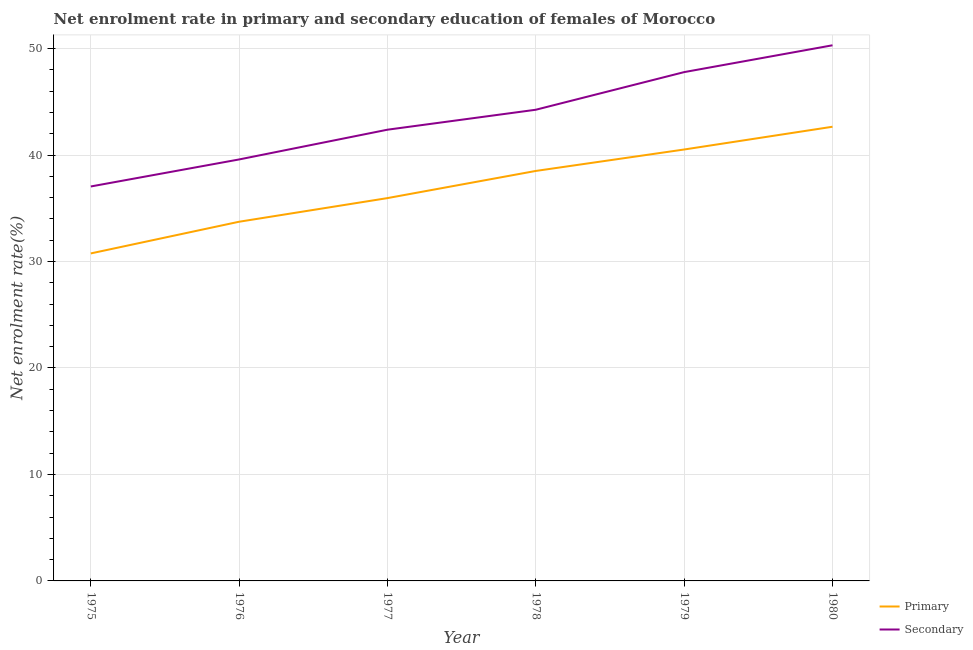Does the line corresponding to enrollment rate in primary education intersect with the line corresponding to enrollment rate in secondary education?
Your response must be concise. No. What is the enrollment rate in primary education in 1980?
Keep it short and to the point. 42.65. Across all years, what is the maximum enrollment rate in secondary education?
Provide a succinct answer. 50.31. Across all years, what is the minimum enrollment rate in primary education?
Give a very brief answer. 30.76. In which year was the enrollment rate in secondary education minimum?
Your answer should be compact. 1975. What is the total enrollment rate in primary education in the graph?
Keep it short and to the point. 222.12. What is the difference between the enrollment rate in secondary education in 1976 and that in 1979?
Your answer should be compact. -8.2. What is the difference between the enrollment rate in primary education in 1976 and the enrollment rate in secondary education in 1977?
Your answer should be very brief. -8.64. What is the average enrollment rate in primary education per year?
Make the answer very short. 37.02. In the year 1978, what is the difference between the enrollment rate in primary education and enrollment rate in secondary education?
Your answer should be compact. -5.75. What is the ratio of the enrollment rate in primary education in 1976 to that in 1980?
Provide a short and direct response. 0.79. Is the enrollment rate in secondary education in 1977 less than that in 1978?
Your answer should be compact. Yes. Is the difference between the enrollment rate in secondary education in 1976 and 1980 greater than the difference between the enrollment rate in primary education in 1976 and 1980?
Offer a very short reply. No. What is the difference between the highest and the second highest enrollment rate in primary education?
Offer a terse response. 2.14. What is the difference between the highest and the lowest enrollment rate in primary education?
Provide a short and direct response. 11.9. Is the sum of the enrollment rate in secondary education in 1978 and 1979 greater than the maximum enrollment rate in primary education across all years?
Provide a succinct answer. Yes. Does the enrollment rate in primary education monotonically increase over the years?
Make the answer very short. Yes. Is the enrollment rate in secondary education strictly greater than the enrollment rate in primary education over the years?
Your response must be concise. Yes. Does the graph contain any zero values?
Your answer should be compact. No. Does the graph contain grids?
Offer a very short reply. Yes. Where does the legend appear in the graph?
Provide a succinct answer. Bottom right. How many legend labels are there?
Give a very brief answer. 2. How are the legend labels stacked?
Give a very brief answer. Vertical. What is the title of the graph?
Your answer should be compact. Net enrolment rate in primary and secondary education of females of Morocco. What is the label or title of the Y-axis?
Provide a short and direct response. Net enrolment rate(%). What is the Net enrolment rate(%) in Primary in 1975?
Your answer should be very brief. 30.76. What is the Net enrolment rate(%) of Secondary in 1975?
Offer a very short reply. 37.05. What is the Net enrolment rate(%) of Primary in 1976?
Your answer should be very brief. 33.73. What is the Net enrolment rate(%) in Secondary in 1976?
Offer a very short reply. 39.58. What is the Net enrolment rate(%) of Primary in 1977?
Provide a short and direct response. 35.95. What is the Net enrolment rate(%) in Secondary in 1977?
Give a very brief answer. 42.38. What is the Net enrolment rate(%) of Primary in 1978?
Make the answer very short. 38.5. What is the Net enrolment rate(%) of Secondary in 1978?
Your answer should be very brief. 44.25. What is the Net enrolment rate(%) of Primary in 1979?
Provide a succinct answer. 40.52. What is the Net enrolment rate(%) of Secondary in 1979?
Keep it short and to the point. 47.79. What is the Net enrolment rate(%) in Primary in 1980?
Give a very brief answer. 42.65. What is the Net enrolment rate(%) in Secondary in 1980?
Ensure brevity in your answer.  50.31. Across all years, what is the maximum Net enrolment rate(%) in Primary?
Your answer should be very brief. 42.65. Across all years, what is the maximum Net enrolment rate(%) in Secondary?
Offer a terse response. 50.31. Across all years, what is the minimum Net enrolment rate(%) in Primary?
Ensure brevity in your answer.  30.76. Across all years, what is the minimum Net enrolment rate(%) in Secondary?
Keep it short and to the point. 37.05. What is the total Net enrolment rate(%) of Primary in the graph?
Provide a short and direct response. 222.12. What is the total Net enrolment rate(%) of Secondary in the graph?
Your answer should be compact. 261.35. What is the difference between the Net enrolment rate(%) in Primary in 1975 and that in 1976?
Provide a short and direct response. -2.98. What is the difference between the Net enrolment rate(%) of Secondary in 1975 and that in 1976?
Keep it short and to the point. -2.54. What is the difference between the Net enrolment rate(%) of Primary in 1975 and that in 1977?
Provide a succinct answer. -5.2. What is the difference between the Net enrolment rate(%) of Secondary in 1975 and that in 1977?
Ensure brevity in your answer.  -5.33. What is the difference between the Net enrolment rate(%) in Primary in 1975 and that in 1978?
Your answer should be compact. -7.75. What is the difference between the Net enrolment rate(%) in Secondary in 1975 and that in 1978?
Keep it short and to the point. -7.21. What is the difference between the Net enrolment rate(%) in Primary in 1975 and that in 1979?
Your response must be concise. -9.76. What is the difference between the Net enrolment rate(%) in Secondary in 1975 and that in 1979?
Provide a succinct answer. -10.74. What is the difference between the Net enrolment rate(%) in Primary in 1975 and that in 1980?
Your answer should be very brief. -11.9. What is the difference between the Net enrolment rate(%) of Secondary in 1975 and that in 1980?
Provide a succinct answer. -13.26. What is the difference between the Net enrolment rate(%) in Primary in 1976 and that in 1977?
Provide a short and direct response. -2.22. What is the difference between the Net enrolment rate(%) of Secondary in 1976 and that in 1977?
Offer a terse response. -2.79. What is the difference between the Net enrolment rate(%) in Primary in 1976 and that in 1978?
Keep it short and to the point. -4.77. What is the difference between the Net enrolment rate(%) of Secondary in 1976 and that in 1978?
Your answer should be compact. -4.67. What is the difference between the Net enrolment rate(%) of Primary in 1976 and that in 1979?
Ensure brevity in your answer.  -6.78. What is the difference between the Net enrolment rate(%) of Secondary in 1976 and that in 1979?
Your answer should be compact. -8.2. What is the difference between the Net enrolment rate(%) in Primary in 1976 and that in 1980?
Give a very brief answer. -8.92. What is the difference between the Net enrolment rate(%) in Secondary in 1976 and that in 1980?
Make the answer very short. -10.72. What is the difference between the Net enrolment rate(%) in Primary in 1977 and that in 1978?
Make the answer very short. -2.55. What is the difference between the Net enrolment rate(%) of Secondary in 1977 and that in 1978?
Keep it short and to the point. -1.87. What is the difference between the Net enrolment rate(%) in Primary in 1977 and that in 1979?
Offer a very short reply. -4.56. What is the difference between the Net enrolment rate(%) of Secondary in 1977 and that in 1979?
Your answer should be very brief. -5.41. What is the difference between the Net enrolment rate(%) of Primary in 1977 and that in 1980?
Your answer should be very brief. -6.7. What is the difference between the Net enrolment rate(%) of Secondary in 1977 and that in 1980?
Your answer should be compact. -7.93. What is the difference between the Net enrolment rate(%) in Primary in 1978 and that in 1979?
Provide a short and direct response. -2.01. What is the difference between the Net enrolment rate(%) in Secondary in 1978 and that in 1979?
Offer a terse response. -3.53. What is the difference between the Net enrolment rate(%) of Primary in 1978 and that in 1980?
Your response must be concise. -4.15. What is the difference between the Net enrolment rate(%) in Secondary in 1978 and that in 1980?
Offer a very short reply. -6.05. What is the difference between the Net enrolment rate(%) in Primary in 1979 and that in 1980?
Provide a short and direct response. -2.14. What is the difference between the Net enrolment rate(%) of Secondary in 1979 and that in 1980?
Offer a terse response. -2.52. What is the difference between the Net enrolment rate(%) in Primary in 1975 and the Net enrolment rate(%) in Secondary in 1976?
Provide a short and direct response. -8.83. What is the difference between the Net enrolment rate(%) in Primary in 1975 and the Net enrolment rate(%) in Secondary in 1977?
Offer a very short reply. -11.62. What is the difference between the Net enrolment rate(%) of Primary in 1975 and the Net enrolment rate(%) of Secondary in 1978?
Ensure brevity in your answer.  -13.49. What is the difference between the Net enrolment rate(%) in Primary in 1975 and the Net enrolment rate(%) in Secondary in 1979?
Provide a short and direct response. -17.03. What is the difference between the Net enrolment rate(%) of Primary in 1975 and the Net enrolment rate(%) of Secondary in 1980?
Keep it short and to the point. -19.55. What is the difference between the Net enrolment rate(%) of Primary in 1976 and the Net enrolment rate(%) of Secondary in 1977?
Make the answer very short. -8.64. What is the difference between the Net enrolment rate(%) of Primary in 1976 and the Net enrolment rate(%) of Secondary in 1978?
Give a very brief answer. -10.52. What is the difference between the Net enrolment rate(%) in Primary in 1976 and the Net enrolment rate(%) in Secondary in 1979?
Ensure brevity in your answer.  -14.05. What is the difference between the Net enrolment rate(%) in Primary in 1976 and the Net enrolment rate(%) in Secondary in 1980?
Keep it short and to the point. -16.57. What is the difference between the Net enrolment rate(%) of Primary in 1977 and the Net enrolment rate(%) of Secondary in 1978?
Provide a short and direct response. -8.3. What is the difference between the Net enrolment rate(%) in Primary in 1977 and the Net enrolment rate(%) in Secondary in 1979?
Your answer should be compact. -11.83. What is the difference between the Net enrolment rate(%) of Primary in 1977 and the Net enrolment rate(%) of Secondary in 1980?
Ensure brevity in your answer.  -14.35. What is the difference between the Net enrolment rate(%) of Primary in 1978 and the Net enrolment rate(%) of Secondary in 1979?
Provide a succinct answer. -9.28. What is the difference between the Net enrolment rate(%) in Primary in 1978 and the Net enrolment rate(%) in Secondary in 1980?
Your answer should be very brief. -11.8. What is the difference between the Net enrolment rate(%) in Primary in 1979 and the Net enrolment rate(%) in Secondary in 1980?
Provide a short and direct response. -9.79. What is the average Net enrolment rate(%) in Primary per year?
Provide a short and direct response. 37.02. What is the average Net enrolment rate(%) of Secondary per year?
Keep it short and to the point. 43.56. In the year 1975, what is the difference between the Net enrolment rate(%) of Primary and Net enrolment rate(%) of Secondary?
Give a very brief answer. -6.29. In the year 1976, what is the difference between the Net enrolment rate(%) in Primary and Net enrolment rate(%) in Secondary?
Your answer should be compact. -5.85. In the year 1977, what is the difference between the Net enrolment rate(%) in Primary and Net enrolment rate(%) in Secondary?
Ensure brevity in your answer.  -6.42. In the year 1978, what is the difference between the Net enrolment rate(%) in Primary and Net enrolment rate(%) in Secondary?
Your answer should be very brief. -5.75. In the year 1979, what is the difference between the Net enrolment rate(%) of Primary and Net enrolment rate(%) of Secondary?
Your answer should be compact. -7.27. In the year 1980, what is the difference between the Net enrolment rate(%) of Primary and Net enrolment rate(%) of Secondary?
Make the answer very short. -7.65. What is the ratio of the Net enrolment rate(%) of Primary in 1975 to that in 1976?
Your answer should be compact. 0.91. What is the ratio of the Net enrolment rate(%) in Secondary in 1975 to that in 1976?
Your answer should be compact. 0.94. What is the ratio of the Net enrolment rate(%) in Primary in 1975 to that in 1977?
Give a very brief answer. 0.86. What is the ratio of the Net enrolment rate(%) in Secondary in 1975 to that in 1977?
Offer a very short reply. 0.87. What is the ratio of the Net enrolment rate(%) of Primary in 1975 to that in 1978?
Give a very brief answer. 0.8. What is the ratio of the Net enrolment rate(%) of Secondary in 1975 to that in 1978?
Your answer should be compact. 0.84. What is the ratio of the Net enrolment rate(%) of Primary in 1975 to that in 1979?
Your answer should be compact. 0.76. What is the ratio of the Net enrolment rate(%) of Secondary in 1975 to that in 1979?
Offer a terse response. 0.78. What is the ratio of the Net enrolment rate(%) of Primary in 1975 to that in 1980?
Your response must be concise. 0.72. What is the ratio of the Net enrolment rate(%) of Secondary in 1975 to that in 1980?
Give a very brief answer. 0.74. What is the ratio of the Net enrolment rate(%) in Primary in 1976 to that in 1977?
Your answer should be very brief. 0.94. What is the ratio of the Net enrolment rate(%) in Secondary in 1976 to that in 1977?
Your answer should be very brief. 0.93. What is the ratio of the Net enrolment rate(%) in Primary in 1976 to that in 1978?
Give a very brief answer. 0.88. What is the ratio of the Net enrolment rate(%) of Secondary in 1976 to that in 1978?
Provide a short and direct response. 0.89. What is the ratio of the Net enrolment rate(%) of Primary in 1976 to that in 1979?
Make the answer very short. 0.83. What is the ratio of the Net enrolment rate(%) in Secondary in 1976 to that in 1979?
Your response must be concise. 0.83. What is the ratio of the Net enrolment rate(%) in Primary in 1976 to that in 1980?
Offer a terse response. 0.79. What is the ratio of the Net enrolment rate(%) of Secondary in 1976 to that in 1980?
Make the answer very short. 0.79. What is the ratio of the Net enrolment rate(%) in Primary in 1977 to that in 1978?
Keep it short and to the point. 0.93. What is the ratio of the Net enrolment rate(%) of Secondary in 1977 to that in 1978?
Your answer should be compact. 0.96. What is the ratio of the Net enrolment rate(%) in Primary in 1977 to that in 1979?
Offer a terse response. 0.89. What is the ratio of the Net enrolment rate(%) of Secondary in 1977 to that in 1979?
Ensure brevity in your answer.  0.89. What is the ratio of the Net enrolment rate(%) of Primary in 1977 to that in 1980?
Your response must be concise. 0.84. What is the ratio of the Net enrolment rate(%) in Secondary in 1977 to that in 1980?
Offer a very short reply. 0.84. What is the ratio of the Net enrolment rate(%) of Primary in 1978 to that in 1979?
Provide a succinct answer. 0.95. What is the ratio of the Net enrolment rate(%) in Secondary in 1978 to that in 1979?
Make the answer very short. 0.93. What is the ratio of the Net enrolment rate(%) in Primary in 1978 to that in 1980?
Your answer should be compact. 0.9. What is the ratio of the Net enrolment rate(%) of Secondary in 1978 to that in 1980?
Keep it short and to the point. 0.88. What is the ratio of the Net enrolment rate(%) in Primary in 1979 to that in 1980?
Offer a very short reply. 0.95. What is the ratio of the Net enrolment rate(%) in Secondary in 1979 to that in 1980?
Your answer should be very brief. 0.95. What is the difference between the highest and the second highest Net enrolment rate(%) of Primary?
Offer a terse response. 2.14. What is the difference between the highest and the second highest Net enrolment rate(%) of Secondary?
Your answer should be compact. 2.52. What is the difference between the highest and the lowest Net enrolment rate(%) of Primary?
Give a very brief answer. 11.9. What is the difference between the highest and the lowest Net enrolment rate(%) of Secondary?
Your answer should be compact. 13.26. 